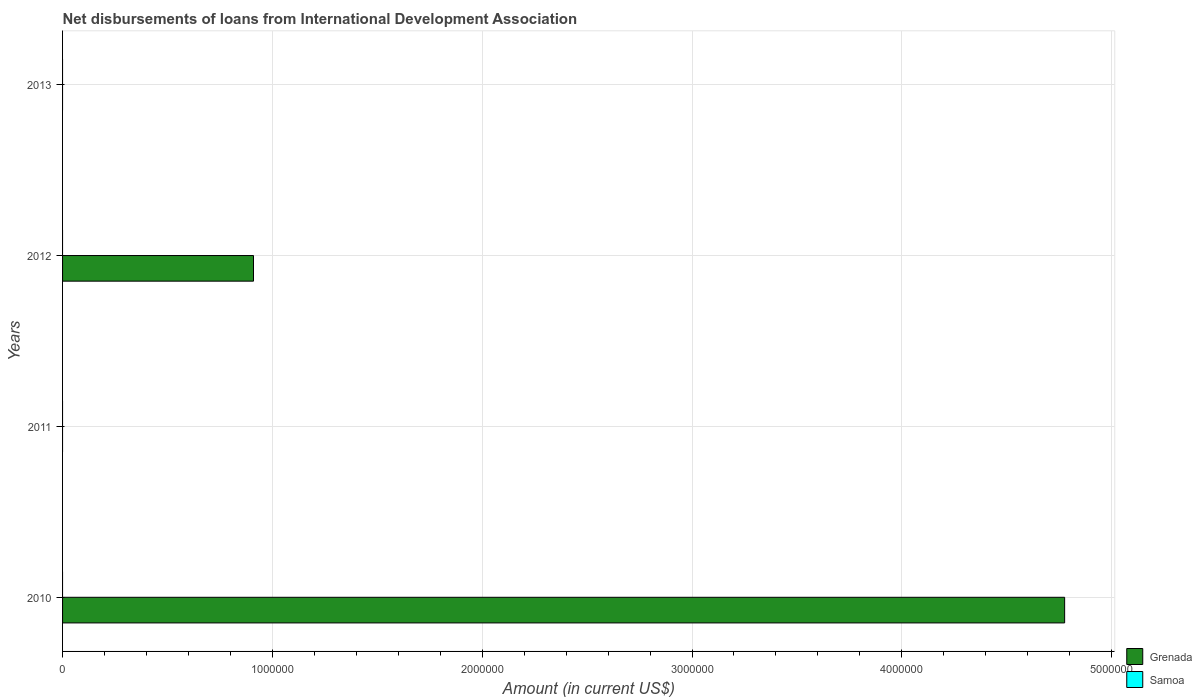Are the number of bars per tick equal to the number of legend labels?
Give a very brief answer. No. How many bars are there on the 4th tick from the top?
Your response must be concise. 1. What is the label of the 4th group of bars from the top?
Your response must be concise. 2010. What is the amount of loans disbursed in Grenada in 2011?
Your answer should be compact. 0. Across all years, what is the maximum amount of loans disbursed in Grenada?
Make the answer very short. 4.78e+06. Across all years, what is the minimum amount of loans disbursed in Samoa?
Offer a terse response. 0. In which year was the amount of loans disbursed in Grenada maximum?
Your answer should be compact. 2010. What is the difference between the amount of loans disbursed in Grenada in 2010 and that in 2012?
Keep it short and to the point. 3.87e+06. What is the difference between the highest and the lowest amount of loans disbursed in Grenada?
Your answer should be compact. 4.78e+06. Does the graph contain grids?
Provide a short and direct response. Yes. Where does the legend appear in the graph?
Offer a very short reply. Bottom right. What is the title of the graph?
Offer a terse response. Net disbursements of loans from International Development Association. What is the label or title of the Y-axis?
Ensure brevity in your answer.  Years. What is the Amount (in current US$) in Grenada in 2010?
Offer a terse response. 4.78e+06. What is the Amount (in current US$) in Samoa in 2010?
Your response must be concise. 0. What is the Amount (in current US$) of Grenada in 2011?
Provide a short and direct response. 0. What is the Amount (in current US$) in Grenada in 2012?
Offer a very short reply. 9.10e+05. What is the Amount (in current US$) in Samoa in 2012?
Keep it short and to the point. 0. What is the Amount (in current US$) in Grenada in 2013?
Provide a short and direct response. 0. Across all years, what is the maximum Amount (in current US$) in Grenada?
Keep it short and to the point. 4.78e+06. Across all years, what is the minimum Amount (in current US$) in Grenada?
Give a very brief answer. 0. What is the total Amount (in current US$) of Grenada in the graph?
Your answer should be compact. 5.69e+06. What is the difference between the Amount (in current US$) of Grenada in 2010 and that in 2012?
Your response must be concise. 3.87e+06. What is the average Amount (in current US$) in Grenada per year?
Give a very brief answer. 1.42e+06. What is the average Amount (in current US$) of Samoa per year?
Offer a terse response. 0. What is the ratio of the Amount (in current US$) of Grenada in 2010 to that in 2012?
Offer a very short reply. 5.25. What is the difference between the highest and the lowest Amount (in current US$) in Grenada?
Provide a short and direct response. 4.78e+06. 